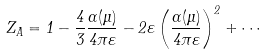Convert formula to latex. <formula><loc_0><loc_0><loc_500><loc_500>Z _ { A } = 1 - \frac { 4 } { 3 } \frac { \alpha ( \mu ) } { 4 \pi \varepsilon } - 2 \varepsilon \left ( \frac { \alpha ( \mu ) } { 4 \pi \varepsilon } \right ) ^ { 2 } + \cdots</formula> 